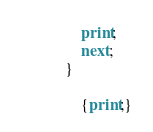<code> <loc_0><loc_0><loc_500><loc_500><_Awk_>		print;
		next;
	}

		{print;}
</code> 